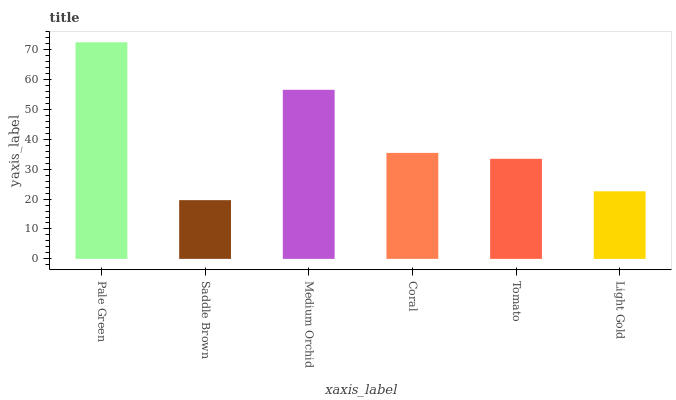Is Saddle Brown the minimum?
Answer yes or no. Yes. Is Pale Green the maximum?
Answer yes or no. Yes. Is Medium Orchid the minimum?
Answer yes or no. No. Is Medium Orchid the maximum?
Answer yes or no. No. Is Medium Orchid greater than Saddle Brown?
Answer yes or no. Yes. Is Saddle Brown less than Medium Orchid?
Answer yes or no. Yes. Is Saddle Brown greater than Medium Orchid?
Answer yes or no. No. Is Medium Orchid less than Saddle Brown?
Answer yes or no. No. Is Coral the high median?
Answer yes or no. Yes. Is Tomato the low median?
Answer yes or no. Yes. Is Pale Green the high median?
Answer yes or no. No. Is Medium Orchid the low median?
Answer yes or no. No. 